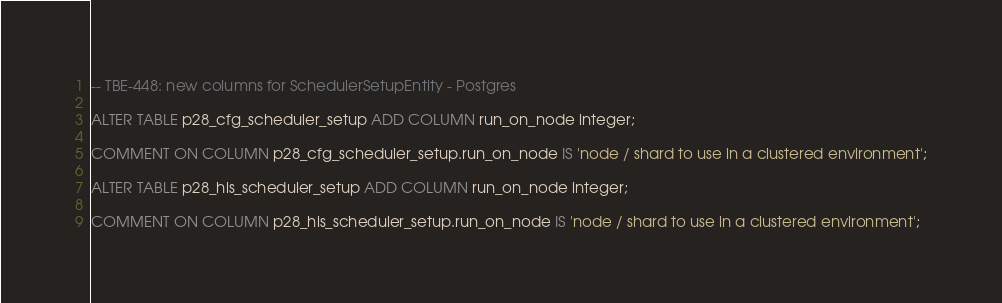<code> <loc_0><loc_0><loc_500><loc_500><_SQL_>-- TBE-448: new columns for SchedulerSetupEntity - Postgres

ALTER TABLE p28_cfg_scheduler_setup ADD COLUMN run_on_node integer;

COMMENT ON COLUMN p28_cfg_scheduler_setup.run_on_node IS 'node / shard to use in a clustered environment';

ALTER TABLE p28_his_scheduler_setup ADD COLUMN run_on_node integer;

COMMENT ON COLUMN p28_his_scheduler_setup.run_on_node IS 'node / shard to use in a clustered environment';
</code> 